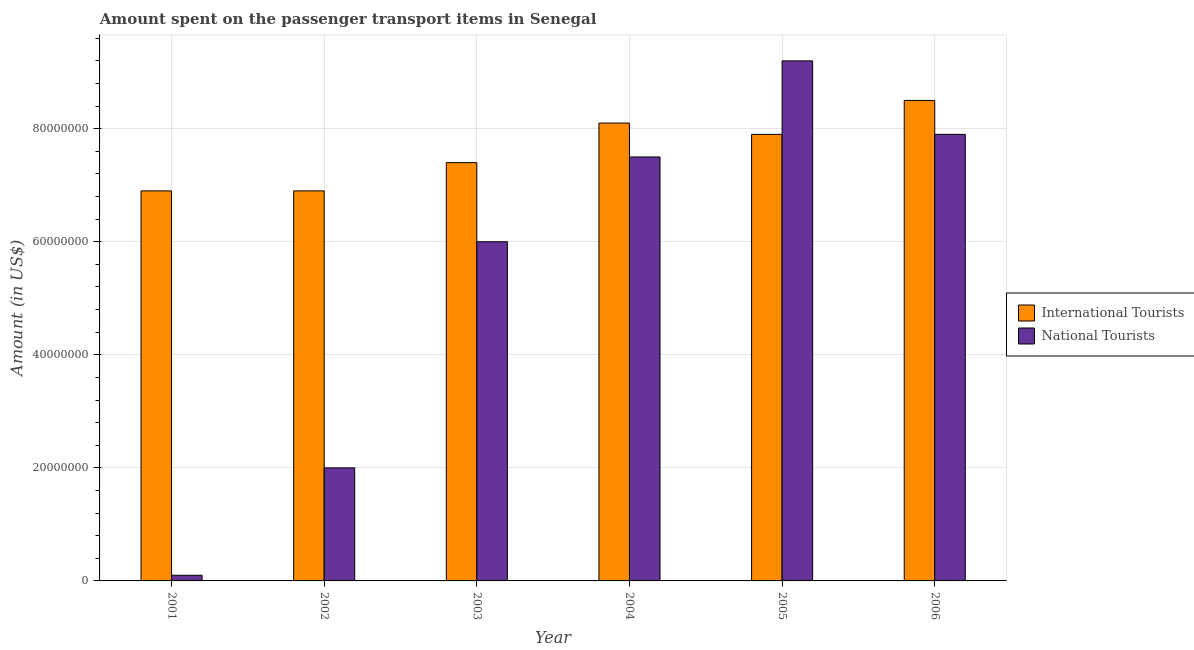How many different coloured bars are there?
Offer a terse response. 2. How many groups of bars are there?
Make the answer very short. 6. Are the number of bars on each tick of the X-axis equal?
Your answer should be very brief. Yes. How many bars are there on the 5th tick from the right?
Provide a short and direct response. 2. In how many cases, is the number of bars for a given year not equal to the number of legend labels?
Provide a short and direct response. 0. What is the amount spent on transport items of national tourists in 2003?
Make the answer very short. 6.00e+07. Across all years, what is the maximum amount spent on transport items of international tourists?
Give a very brief answer. 8.50e+07. Across all years, what is the minimum amount spent on transport items of international tourists?
Give a very brief answer. 6.90e+07. In which year was the amount spent on transport items of international tourists maximum?
Make the answer very short. 2006. What is the total amount spent on transport items of international tourists in the graph?
Your answer should be very brief. 4.57e+08. What is the difference between the amount spent on transport items of national tourists in 2001 and that in 2005?
Your response must be concise. -9.10e+07. What is the difference between the amount spent on transport items of international tourists in 2001 and the amount spent on transport items of national tourists in 2004?
Give a very brief answer. -1.20e+07. What is the average amount spent on transport items of national tourists per year?
Offer a terse response. 5.45e+07. In how many years, is the amount spent on transport items of international tourists greater than 28000000 US$?
Give a very brief answer. 6. What is the ratio of the amount spent on transport items of national tourists in 2001 to that in 2003?
Offer a terse response. 0.02. Is the difference between the amount spent on transport items of national tourists in 2002 and 2003 greater than the difference between the amount spent on transport items of international tourists in 2002 and 2003?
Make the answer very short. No. What is the difference between the highest and the second highest amount spent on transport items of national tourists?
Your answer should be very brief. 1.30e+07. What is the difference between the highest and the lowest amount spent on transport items of international tourists?
Your answer should be very brief. 1.60e+07. In how many years, is the amount spent on transport items of international tourists greater than the average amount spent on transport items of international tourists taken over all years?
Your response must be concise. 3. What does the 1st bar from the left in 2002 represents?
Make the answer very short. International Tourists. What does the 2nd bar from the right in 2003 represents?
Your answer should be compact. International Tourists. Are all the bars in the graph horizontal?
Make the answer very short. No. How many years are there in the graph?
Make the answer very short. 6. What is the title of the graph?
Give a very brief answer. Amount spent on the passenger transport items in Senegal. Does "Girls" appear as one of the legend labels in the graph?
Provide a short and direct response. No. What is the Amount (in US$) in International Tourists in 2001?
Provide a short and direct response. 6.90e+07. What is the Amount (in US$) of National Tourists in 2001?
Provide a short and direct response. 1.00e+06. What is the Amount (in US$) of International Tourists in 2002?
Keep it short and to the point. 6.90e+07. What is the Amount (in US$) in International Tourists in 2003?
Your response must be concise. 7.40e+07. What is the Amount (in US$) in National Tourists in 2003?
Provide a short and direct response. 6.00e+07. What is the Amount (in US$) in International Tourists in 2004?
Your answer should be compact. 8.10e+07. What is the Amount (in US$) in National Tourists in 2004?
Give a very brief answer. 7.50e+07. What is the Amount (in US$) in International Tourists in 2005?
Your answer should be very brief. 7.90e+07. What is the Amount (in US$) of National Tourists in 2005?
Provide a short and direct response. 9.20e+07. What is the Amount (in US$) in International Tourists in 2006?
Keep it short and to the point. 8.50e+07. What is the Amount (in US$) of National Tourists in 2006?
Provide a succinct answer. 7.90e+07. Across all years, what is the maximum Amount (in US$) in International Tourists?
Provide a succinct answer. 8.50e+07. Across all years, what is the maximum Amount (in US$) in National Tourists?
Make the answer very short. 9.20e+07. Across all years, what is the minimum Amount (in US$) in International Tourists?
Ensure brevity in your answer.  6.90e+07. Across all years, what is the minimum Amount (in US$) in National Tourists?
Offer a terse response. 1.00e+06. What is the total Amount (in US$) in International Tourists in the graph?
Give a very brief answer. 4.57e+08. What is the total Amount (in US$) in National Tourists in the graph?
Keep it short and to the point. 3.27e+08. What is the difference between the Amount (in US$) of National Tourists in 2001 and that in 2002?
Your answer should be very brief. -1.90e+07. What is the difference between the Amount (in US$) in International Tourists in 2001 and that in 2003?
Give a very brief answer. -5.00e+06. What is the difference between the Amount (in US$) in National Tourists in 2001 and that in 2003?
Your response must be concise. -5.90e+07. What is the difference between the Amount (in US$) in International Tourists in 2001 and that in 2004?
Make the answer very short. -1.20e+07. What is the difference between the Amount (in US$) in National Tourists in 2001 and that in 2004?
Provide a short and direct response. -7.40e+07. What is the difference between the Amount (in US$) of International Tourists in 2001 and that in 2005?
Make the answer very short. -1.00e+07. What is the difference between the Amount (in US$) of National Tourists in 2001 and that in 2005?
Your answer should be very brief. -9.10e+07. What is the difference between the Amount (in US$) of International Tourists in 2001 and that in 2006?
Your answer should be very brief. -1.60e+07. What is the difference between the Amount (in US$) in National Tourists in 2001 and that in 2006?
Offer a terse response. -7.80e+07. What is the difference between the Amount (in US$) of International Tourists in 2002 and that in 2003?
Your response must be concise. -5.00e+06. What is the difference between the Amount (in US$) of National Tourists in 2002 and that in 2003?
Ensure brevity in your answer.  -4.00e+07. What is the difference between the Amount (in US$) in International Tourists in 2002 and that in 2004?
Ensure brevity in your answer.  -1.20e+07. What is the difference between the Amount (in US$) of National Tourists in 2002 and that in 2004?
Make the answer very short. -5.50e+07. What is the difference between the Amount (in US$) in International Tourists in 2002 and that in 2005?
Keep it short and to the point. -1.00e+07. What is the difference between the Amount (in US$) in National Tourists in 2002 and that in 2005?
Your response must be concise. -7.20e+07. What is the difference between the Amount (in US$) of International Tourists in 2002 and that in 2006?
Your answer should be compact. -1.60e+07. What is the difference between the Amount (in US$) in National Tourists in 2002 and that in 2006?
Give a very brief answer. -5.90e+07. What is the difference between the Amount (in US$) in International Tourists in 2003 and that in 2004?
Provide a short and direct response. -7.00e+06. What is the difference between the Amount (in US$) in National Tourists in 2003 and that in 2004?
Ensure brevity in your answer.  -1.50e+07. What is the difference between the Amount (in US$) of International Tourists in 2003 and that in 2005?
Provide a short and direct response. -5.00e+06. What is the difference between the Amount (in US$) of National Tourists in 2003 and that in 2005?
Offer a very short reply. -3.20e+07. What is the difference between the Amount (in US$) in International Tourists in 2003 and that in 2006?
Offer a very short reply. -1.10e+07. What is the difference between the Amount (in US$) of National Tourists in 2003 and that in 2006?
Ensure brevity in your answer.  -1.90e+07. What is the difference between the Amount (in US$) in National Tourists in 2004 and that in 2005?
Give a very brief answer. -1.70e+07. What is the difference between the Amount (in US$) of International Tourists in 2004 and that in 2006?
Ensure brevity in your answer.  -4.00e+06. What is the difference between the Amount (in US$) in National Tourists in 2004 and that in 2006?
Offer a terse response. -4.00e+06. What is the difference between the Amount (in US$) of International Tourists in 2005 and that in 2006?
Keep it short and to the point. -6.00e+06. What is the difference between the Amount (in US$) of National Tourists in 2005 and that in 2006?
Provide a short and direct response. 1.30e+07. What is the difference between the Amount (in US$) of International Tourists in 2001 and the Amount (in US$) of National Tourists in 2002?
Ensure brevity in your answer.  4.90e+07. What is the difference between the Amount (in US$) in International Tourists in 2001 and the Amount (in US$) in National Tourists in 2003?
Your answer should be compact. 9.00e+06. What is the difference between the Amount (in US$) of International Tourists in 2001 and the Amount (in US$) of National Tourists in 2004?
Your answer should be compact. -6.00e+06. What is the difference between the Amount (in US$) in International Tourists in 2001 and the Amount (in US$) in National Tourists in 2005?
Give a very brief answer. -2.30e+07. What is the difference between the Amount (in US$) in International Tourists in 2001 and the Amount (in US$) in National Tourists in 2006?
Ensure brevity in your answer.  -1.00e+07. What is the difference between the Amount (in US$) in International Tourists in 2002 and the Amount (in US$) in National Tourists in 2003?
Your answer should be very brief. 9.00e+06. What is the difference between the Amount (in US$) in International Tourists in 2002 and the Amount (in US$) in National Tourists in 2004?
Ensure brevity in your answer.  -6.00e+06. What is the difference between the Amount (in US$) in International Tourists in 2002 and the Amount (in US$) in National Tourists in 2005?
Keep it short and to the point. -2.30e+07. What is the difference between the Amount (in US$) of International Tourists in 2002 and the Amount (in US$) of National Tourists in 2006?
Offer a terse response. -1.00e+07. What is the difference between the Amount (in US$) in International Tourists in 2003 and the Amount (in US$) in National Tourists in 2004?
Keep it short and to the point. -1.00e+06. What is the difference between the Amount (in US$) of International Tourists in 2003 and the Amount (in US$) of National Tourists in 2005?
Provide a short and direct response. -1.80e+07. What is the difference between the Amount (in US$) of International Tourists in 2003 and the Amount (in US$) of National Tourists in 2006?
Make the answer very short. -5.00e+06. What is the difference between the Amount (in US$) of International Tourists in 2004 and the Amount (in US$) of National Tourists in 2005?
Offer a terse response. -1.10e+07. What is the difference between the Amount (in US$) in International Tourists in 2004 and the Amount (in US$) in National Tourists in 2006?
Your answer should be very brief. 2.00e+06. What is the average Amount (in US$) in International Tourists per year?
Keep it short and to the point. 7.62e+07. What is the average Amount (in US$) in National Tourists per year?
Your answer should be very brief. 5.45e+07. In the year 2001, what is the difference between the Amount (in US$) in International Tourists and Amount (in US$) in National Tourists?
Offer a terse response. 6.80e+07. In the year 2002, what is the difference between the Amount (in US$) in International Tourists and Amount (in US$) in National Tourists?
Give a very brief answer. 4.90e+07. In the year 2003, what is the difference between the Amount (in US$) in International Tourists and Amount (in US$) in National Tourists?
Your answer should be very brief. 1.40e+07. In the year 2004, what is the difference between the Amount (in US$) in International Tourists and Amount (in US$) in National Tourists?
Ensure brevity in your answer.  6.00e+06. In the year 2005, what is the difference between the Amount (in US$) of International Tourists and Amount (in US$) of National Tourists?
Make the answer very short. -1.30e+07. What is the ratio of the Amount (in US$) in International Tourists in 2001 to that in 2002?
Your response must be concise. 1. What is the ratio of the Amount (in US$) of International Tourists in 2001 to that in 2003?
Your answer should be very brief. 0.93. What is the ratio of the Amount (in US$) of National Tourists in 2001 to that in 2003?
Provide a short and direct response. 0.02. What is the ratio of the Amount (in US$) of International Tourists in 2001 to that in 2004?
Provide a short and direct response. 0.85. What is the ratio of the Amount (in US$) in National Tourists in 2001 to that in 2004?
Your answer should be very brief. 0.01. What is the ratio of the Amount (in US$) of International Tourists in 2001 to that in 2005?
Your answer should be very brief. 0.87. What is the ratio of the Amount (in US$) of National Tourists in 2001 to that in 2005?
Give a very brief answer. 0.01. What is the ratio of the Amount (in US$) of International Tourists in 2001 to that in 2006?
Provide a succinct answer. 0.81. What is the ratio of the Amount (in US$) of National Tourists in 2001 to that in 2006?
Make the answer very short. 0.01. What is the ratio of the Amount (in US$) in International Tourists in 2002 to that in 2003?
Your answer should be very brief. 0.93. What is the ratio of the Amount (in US$) in National Tourists in 2002 to that in 2003?
Offer a terse response. 0.33. What is the ratio of the Amount (in US$) of International Tourists in 2002 to that in 2004?
Provide a succinct answer. 0.85. What is the ratio of the Amount (in US$) of National Tourists in 2002 to that in 2004?
Ensure brevity in your answer.  0.27. What is the ratio of the Amount (in US$) of International Tourists in 2002 to that in 2005?
Your response must be concise. 0.87. What is the ratio of the Amount (in US$) of National Tourists in 2002 to that in 2005?
Keep it short and to the point. 0.22. What is the ratio of the Amount (in US$) of International Tourists in 2002 to that in 2006?
Provide a short and direct response. 0.81. What is the ratio of the Amount (in US$) of National Tourists in 2002 to that in 2006?
Provide a succinct answer. 0.25. What is the ratio of the Amount (in US$) in International Tourists in 2003 to that in 2004?
Keep it short and to the point. 0.91. What is the ratio of the Amount (in US$) in National Tourists in 2003 to that in 2004?
Your answer should be compact. 0.8. What is the ratio of the Amount (in US$) of International Tourists in 2003 to that in 2005?
Ensure brevity in your answer.  0.94. What is the ratio of the Amount (in US$) in National Tourists in 2003 to that in 2005?
Keep it short and to the point. 0.65. What is the ratio of the Amount (in US$) in International Tourists in 2003 to that in 2006?
Make the answer very short. 0.87. What is the ratio of the Amount (in US$) in National Tourists in 2003 to that in 2006?
Ensure brevity in your answer.  0.76. What is the ratio of the Amount (in US$) in International Tourists in 2004 to that in 2005?
Offer a very short reply. 1.03. What is the ratio of the Amount (in US$) in National Tourists in 2004 to that in 2005?
Offer a very short reply. 0.82. What is the ratio of the Amount (in US$) in International Tourists in 2004 to that in 2006?
Provide a succinct answer. 0.95. What is the ratio of the Amount (in US$) of National Tourists in 2004 to that in 2006?
Your answer should be compact. 0.95. What is the ratio of the Amount (in US$) of International Tourists in 2005 to that in 2006?
Provide a succinct answer. 0.93. What is the ratio of the Amount (in US$) of National Tourists in 2005 to that in 2006?
Give a very brief answer. 1.16. What is the difference between the highest and the second highest Amount (in US$) in International Tourists?
Provide a short and direct response. 4.00e+06. What is the difference between the highest and the second highest Amount (in US$) of National Tourists?
Ensure brevity in your answer.  1.30e+07. What is the difference between the highest and the lowest Amount (in US$) of International Tourists?
Ensure brevity in your answer.  1.60e+07. What is the difference between the highest and the lowest Amount (in US$) of National Tourists?
Provide a succinct answer. 9.10e+07. 